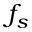Convert formula to latex. <formula><loc_0><loc_0><loc_500><loc_500>f _ { s }</formula> 